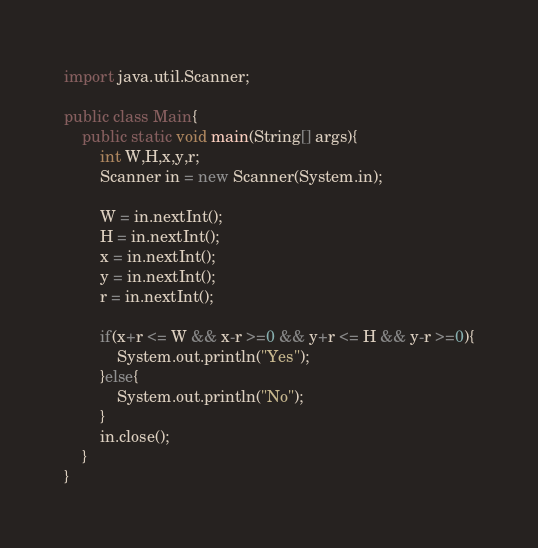<code> <loc_0><loc_0><loc_500><loc_500><_Java_>import java.util.Scanner;

public class Main{
	public static void main(String[] args){
		int W,H,x,y,r;
		Scanner in = new Scanner(System.in);
		
		W = in.nextInt();
		H = in.nextInt();
		x = in.nextInt();
		y = in.nextInt();
		r = in.nextInt();
		
		if(x+r <= W && x-r >=0 && y+r <= H && y-r >=0){
			System.out.println("Yes");
		}else{
			System.out.println("No");
		}
		in.close();
	}
}</code> 